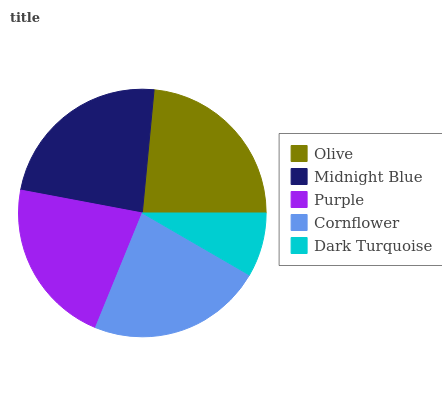Is Dark Turquoise the minimum?
Answer yes or no. Yes. Is Midnight Blue the maximum?
Answer yes or no. Yes. Is Purple the minimum?
Answer yes or no. No. Is Purple the maximum?
Answer yes or no. No. Is Midnight Blue greater than Purple?
Answer yes or no. Yes. Is Purple less than Midnight Blue?
Answer yes or no. Yes. Is Purple greater than Midnight Blue?
Answer yes or no. No. Is Midnight Blue less than Purple?
Answer yes or no. No. Is Cornflower the high median?
Answer yes or no. Yes. Is Cornflower the low median?
Answer yes or no. Yes. Is Midnight Blue the high median?
Answer yes or no. No. Is Midnight Blue the low median?
Answer yes or no. No. 